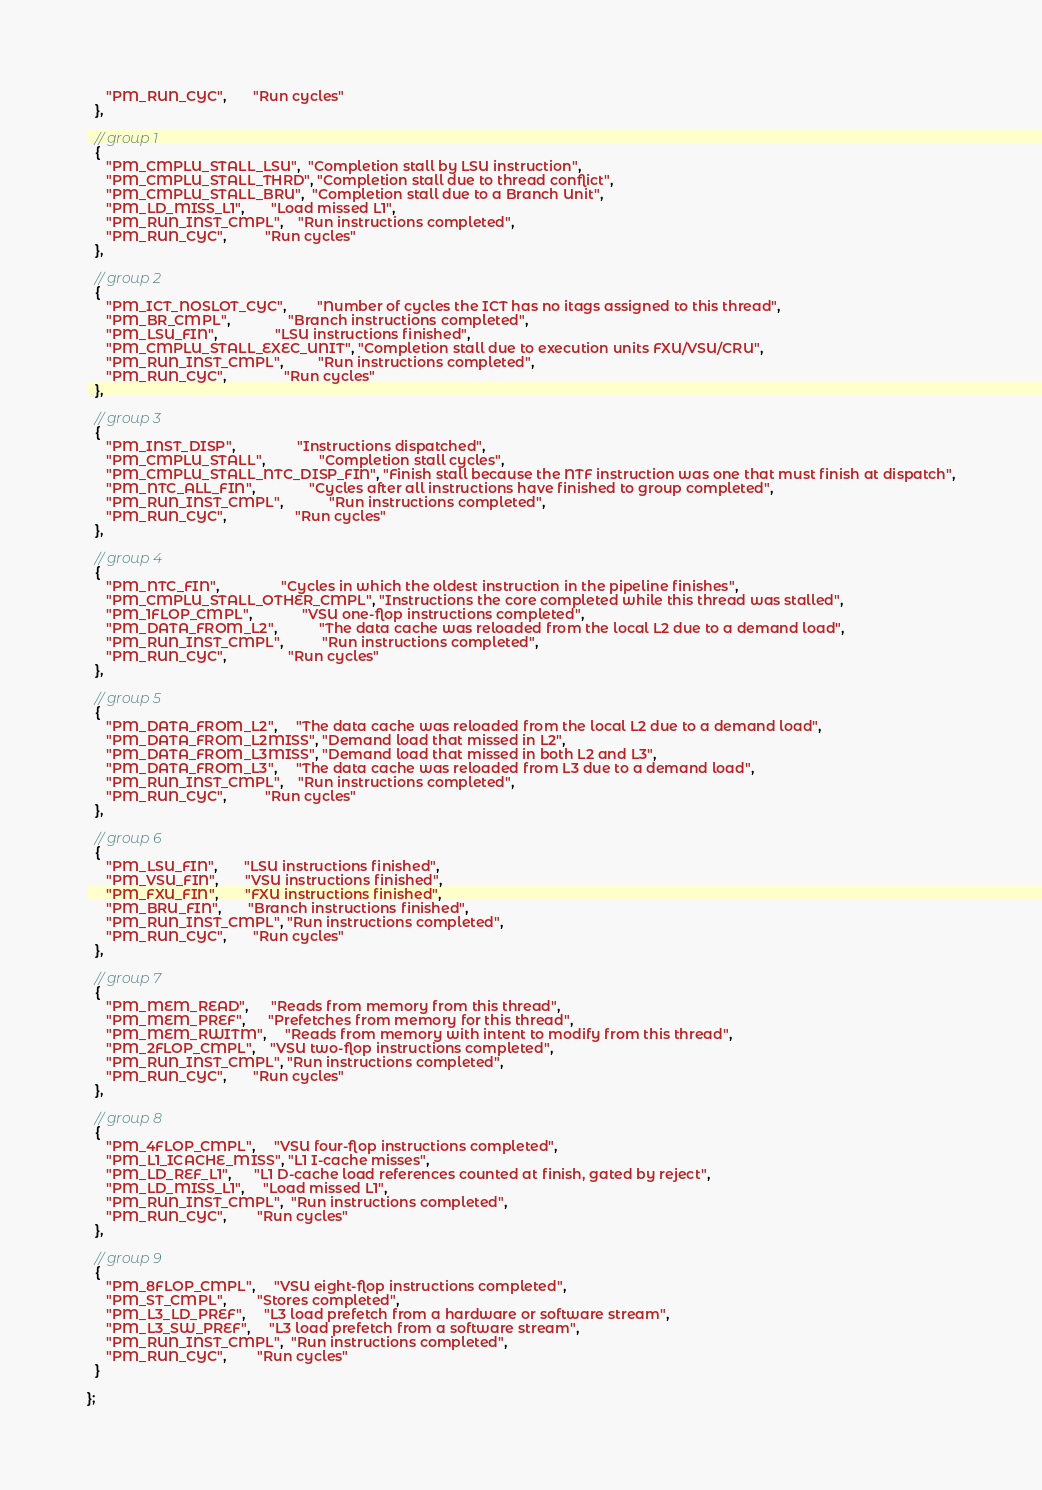<code> <loc_0><loc_0><loc_500><loc_500><_C_>     "PM_RUN_CYC",       "Run cycles"
  },

  // group 1
  { 
     "PM_CMPLU_STALL_LSU",  "Completion stall by LSU instruction",
     "PM_CMPLU_STALL_THRD", "Completion stall due to thread conflict",
     "PM_CMPLU_STALL_BRU",  "Completion stall due to a Branch Unit",
     "PM_LD_MISS_L1",       "Load missed L1",
     "PM_RUN_INST_CMPL",    "Run instructions completed",
     "PM_RUN_CYC",          "Run cycles"
  },

  // group 2
  { 
     "PM_ICT_NOSLOT_CYC",        "Number of cycles the ICT has no itags assigned to this thread",
     "PM_BR_CMPL",               "Branch instructions completed",
     "PM_LSU_FIN",               "LSU instructions finished",
     "PM_CMPLU_STALL_EXEC_UNIT", "Completion stall due to execution units FXU/VSU/CRU",
     "PM_RUN_INST_CMPL",         "Run instructions completed",
     "PM_RUN_CYC",               "Run cycles"
  },

  // group 3
  { 
     "PM_INST_DISP",                "Instructions dispatched",
     "PM_CMPLU_STALL",              "Completion stall cycles",
     "PM_CMPLU_STALL_NTC_DISP_FIN", "Finish stall because the NTF instruction was one that must finish at dispatch",
     "PM_NTC_ALL_FIN",              "Cycles after all instructions have finished to group completed",
     "PM_RUN_INST_CMPL",            "Run instructions completed",
     "PM_RUN_CYC",                  "Run cycles"
  },

  // group 4
  { 
     "PM_NTC_FIN",                "Cycles in which the oldest instruction in the pipeline finishes",
     "PM_CMPLU_STALL_OTHER_CMPL", "Instructions the core completed while this thread was stalled",
     "PM_1FLOP_CMPL",             "VSU one-flop instructions completed",
     "PM_DATA_FROM_L2",           "The data cache was reloaded from the local L2 due to a demand load",
     "PM_RUN_INST_CMPL",          "Run instructions completed",
     "PM_RUN_CYC",                "Run cycles"
  },

  // group 5
  { 
     "PM_DATA_FROM_L2",     "The data cache was reloaded from the local L2 due to a demand load",
     "PM_DATA_FROM_L2MISS", "Demand load that missed in L2",
     "PM_DATA_FROM_L3MISS", "Demand load that missed in both L2 and L3",
     "PM_DATA_FROM_L3",     "The data cache was reloaded from L3 due to a demand load",
     "PM_RUN_INST_CMPL",    "Run instructions completed",
     "PM_RUN_CYC",          "Run cycles"
  },

  // group 6
  { 
     "PM_LSU_FIN",       "LSU instructions finished",
     "PM_VSU_FIN",       "VSU instructions finished",
     "PM_FXU_FIN",       "FXU instructions finished",
     "PM_BRU_FIN",       "Branch instructions finished",
     "PM_RUN_INST_CMPL", "Run instructions completed",
     "PM_RUN_CYC",       "Run cycles"
  },

  // group 7
  { 
     "PM_MEM_READ",      "Reads from memory from this thread",
     "PM_MEM_PREF",      "Prefetches from memory for this thread",
     "PM_MEM_RWITM",     "Reads from memory with intent to modify from this thread",
     "PM_2FLOP_CMPL",    "VSU two-flop instructions completed",
     "PM_RUN_INST_CMPL", "Run instructions completed",
     "PM_RUN_CYC",       "Run cycles"
  },

  // group 8
  { 
     "PM_4FLOP_CMPL",     "VSU four-flop instructions completed",
     "PM_L1_ICACHE_MISS", "L1 I-cache misses",
     "PM_LD_REF_L1",      "L1 D-cache load references counted at finish, gated by reject",
     "PM_LD_MISS_L1",     "Load missed L1",
     "PM_RUN_INST_CMPL",  "Run instructions completed",
     "PM_RUN_CYC",        "Run cycles"
  },

  // group 9
  { 
     "PM_8FLOP_CMPL",     "VSU eight-flop instructions completed",
     "PM_ST_CMPL",        "Stores completed",
     "PM_L3_LD_PREF",     "L3 load prefetch from a hardware or software stream",
     "PM_L3_SW_PREF",     "L3 load prefetch from a software stream",
     "PM_RUN_INST_CMPL",  "Run instructions completed",
     "PM_RUN_CYC",        "Run cycles"
  }

};
</code> 